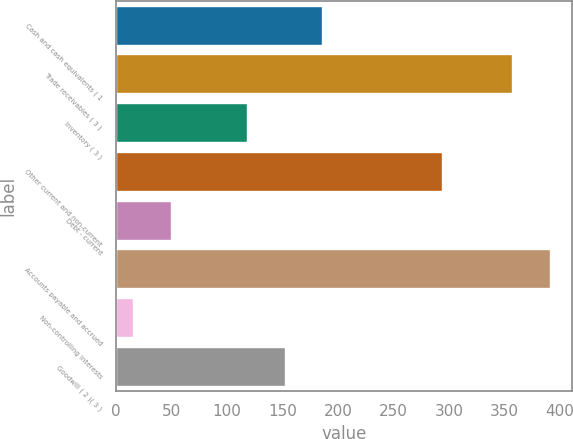Convert chart to OTSL. <chart><loc_0><loc_0><loc_500><loc_500><bar_chart><fcel>Cash and cash equivalents ( 1<fcel>Trade receivables ( 3 )<fcel>Inventory ( 3 )<fcel>Other current and non-current<fcel>Debt - current<fcel>Accounts payable and accrued<fcel>Non-controlling interests<fcel>Goodwill ( 2 )( 3 )<nl><fcel>186<fcel>357<fcel>117.6<fcel>294<fcel>49.2<fcel>391.2<fcel>15<fcel>151.8<nl></chart> 